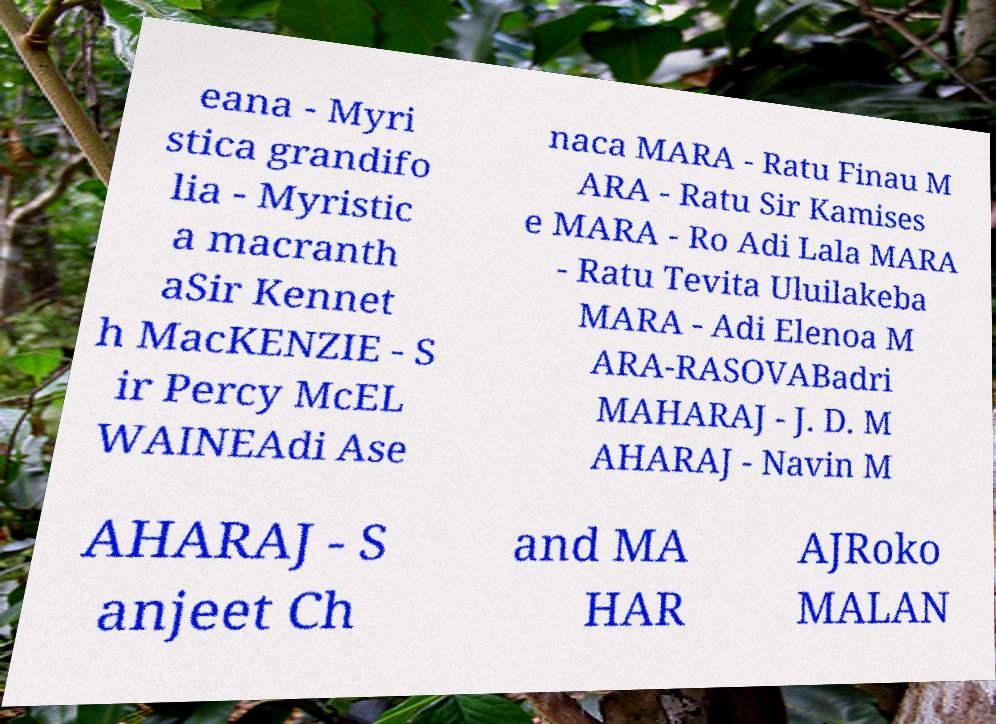Please read and relay the text visible in this image. What does it say? eana - Myri stica grandifo lia - Myristic a macranth aSir Kennet h MacKENZIE - S ir Percy McEL WAINEAdi Ase naca MARA - Ratu Finau M ARA - Ratu Sir Kamises e MARA - Ro Adi Lala MARA - Ratu Tevita Uluilakeba MARA - Adi Elenoa M ARA-RASOVABadri MAHARAJ - J. D. M AHARAJ - Navin M AHARAJ - S anjeet Ch and MA HAR AJRoko MALAN 